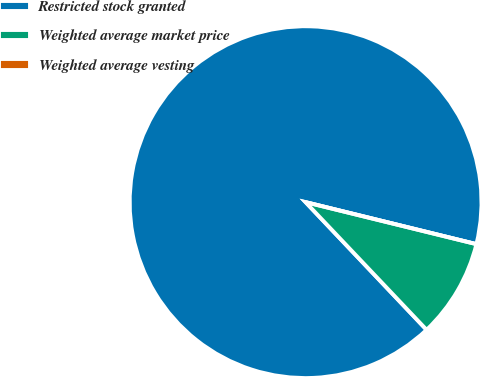Convert chart. <chart><loc_0><loc_0><loc_500><loc_500><pie_chart><fcel>Restricted stock granted<fcel>Weighted average market price<fcel>Weighted average vesting<nl><fcel>90.91%<fcel>9.09%<fcel>0.0%<nl></chart> 